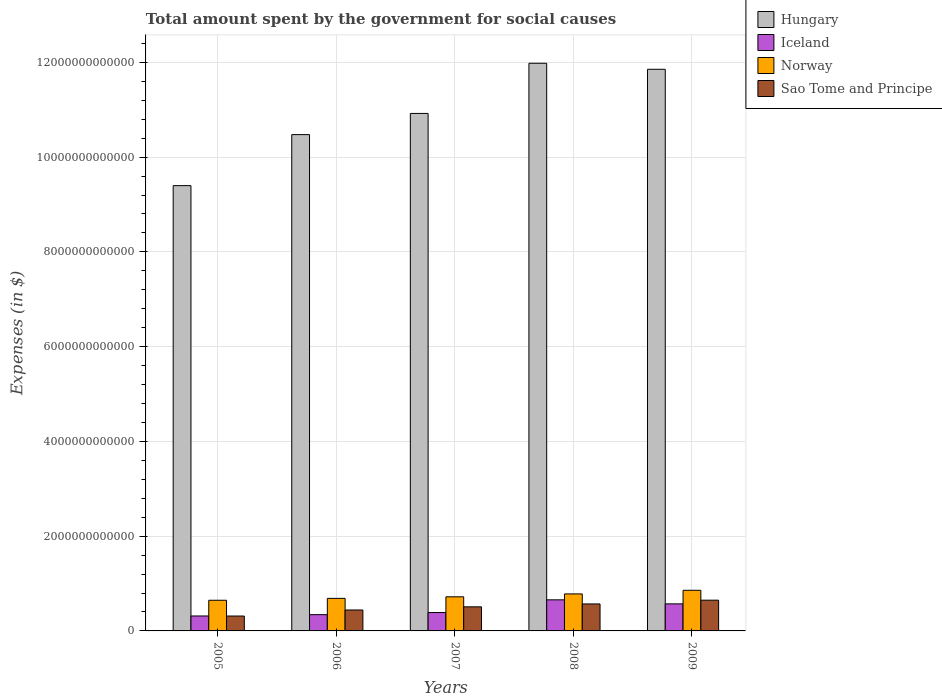How many different coloured bars are there?
Give a very brief answer. 4. How many groups of bars are there?
Offer a very short reply. 5. What is the label of the 2nd group of bars from the left?
Ensure brevity in your answer.  2006. In how many cases, is the number of bars for a given year not equal to the number of legend labels?
Provide a short and direct response. 0. What is the amount spent for social causes by the government in Iceland in 2007?
Offer a very short reply. 3.88e+11. Across all years, what is the maximum amount spent for social causes by the government in Norway?
Your answer should be compact. 8.57e+11. Across all years, what is the minimum amount spent for social causes by the government in Iceland?
Give a very brief answer. 3.16e+11. What is the total amount spent for social causes by the government in Hungary in the graph?
Your answer should be very brief. 5.46e+13. What is the difference between the amount spent for social causes by the government in Hungary in 2005 and that in 2008?
Ensure brevity in your answer.  -2.58e+12. What is the difference between the amount spent for social causes by the government in Iceland in 2008 and the amount spent for social causes by the government in Sao Tome and Principe in 2009?
Your answer should be very brief. 7.34e+09. What is the average amount spent for social causes by the government in Hungary per year?
Your answer should be compact. 1.09e+13. In the year 2009, what is the difference between the amount spent for social causes by the government in Hungary and amount spent for social causes by the government in Norway?
Ensure brevity in your answer.  1.10e+13. In how many years, is the amount spent for social causes by the government in Norway greater than 3200000000000 $?
Offer a very short reply. 0. What is the ratio of the amount spent for social causes by the government in Hungary in 2005 to that in 2009?
Give a very brief answer. 0.79. Is the amount spent for social causes by the government in Hungary in 2006 less than that in 2007?
Offer a terse response. Yes. What is the difference between the highest and the second highest amount spent for social causes by the government in Sao Tome and Principe?
Your answer should be very brief. 7.93e+1. What is the difference between the highest and the lowest amount spent for social causes by the government in Sao Tome and Principe?
Your answer should be compact. 3.34e+11. Is it the case that in every year, the sum of the amount spent for social causes by the government in Hungary and amount spent for social causes by the government in Iceland is greater than the sum of amount spent for social causes by the government in Norway and amount spent for social causes by the government in Sao Tome and Principe?
Provide a succinct answer. Yes. What does the 1st bar from the left in 2005 represents?
Your answer should be very brief. Hungary. What does the 2nd bar from the right in 2006 represents?
Your response must be concise. Norway. Is it the case that in every year, the sum of the amount spent for social causes by the government in Iceland and amount spent for social causes by the government in Sao Tome and Principe is greater than the amount spent for social causes by the government in Hungary?
Your answer should be very brief. No. Are all the bars in the graph horizontal?
Provide a succinct answer. No. How many years are there in the graph?
Provide a short and direct response. 5. What is the difference between two consecutive major ticks on the Y-axis?
Your response must be concise. 2.00e+12. Where does the legend appear in the graph?
Ensure brevity in your answer.  Top right. How are the legend labels stacked?
Your answer should be compact. Vertical. What is the title of the graph?
Your response must be concise. Total amount spent by the government for social causes. Does "Sao Tome and Principe" appear as one of the legend labels in the graph?
Give a very brief answer. Yes. What is the label or title of the Y-axis?
Keep it short and to the point. Expenses (in $). What is the Expenses (in $) of Hungary in 2005?
Provide a succinct answer. 9.40e+12. What is the Expenses (in $) of Iceland in 2005?
Ensure brevity in your answer.  3.16e+11. What is the Expenses (in $) of Norway in 2005?
Offer a terse response. 6.47e+11. What is the Expenses (in $) of Sao Tome and Principe in 2005?
Give a very brief answer. 3.14e+11. What is the Expenses (in $) in Hungary in 2006?
Offer a terse response. 1.05e+13. What is the Expenses (in $) of Iceland in 2006?
Make the answer very short. 3.44e+11. What is the Expenses (in $) of Norway in 2006?
Offer a terse response. 6.87e+11. What is the Expenses (in $) of Sao Tome and Principe in 2006?
Ensure brevity in your answer.  4.42e+11. What is the Expenses (in $) of Hungary in 2007?
Provide a short and direct response. 1.09e+13. What is the Expenses (in $) in Iceland in 2007?
Offer a very short reply. 3.88e+11. What is the Expenses (in $) of Norway in 2007?
Provide a short and direct response. 7.20e+11. What is the Expenses (in $) in Sao Tome and Principe in 2007?
Make the answer very short. 5.08e+11. What is the Expenses (in $) in Hungary in 2008?
Make the answer very short. 1.20e+13. What is the Expenses (in $) of Iceland in 2008?
Provide a short and direct response. 6.56e+11. What is the Expenses (in $) in Norway in 2008?
Provide a short and direct response. 7.81e+11. What is the Expenses (in $) in Sao Tome and Principe in 2008?
Keep it short and to the point. 5.69e+11. What is the Expenses (in $) in Hungary in 2009?
Offer a terse response. 1.19e+13. What is the Expenses (in $) in Iceland in 2009?
Offer a very short reply. 5.71e+11. What is the Expenses (in $) of Norway in 2009?
Keep it short and to the point. 8.57e+11. What is the Expenses (in $) in Sao Tome and Principe in 2009?
Offer a terse response. 6.49e+11. Across all years, what is the maximum Expenses (in $) in Hungary?
Provide a short and direct response. 1.20e+13. Across all years, what is the maximum Expenses (in $) of Iceland?
Offer a terse response. 6.56e+11. Across all years, what is the maximum Expenses (in $) in Norway?
Your answer should be compact. 8.57e+11. Across all years, what is the maximum Expenses (in $) of Sao Tome and Principe?
Keep it short and to the point. 6.49e+11. Across all years, what is the minimum Expenses (in $) of Hungary?
Give a very brief answer. 9.40e+12. Across all years, what is the minimum Expenses (in $) in Iceland?
Keep it short and to the point. 3.16e+11. Across all years, what is the minimum Expenses (in $) in Norway?
Your response must be concise. 6.47e+11. Across all years, what is the minimum Expenses (in $) in Sao Tome and Principe?
Make the answer very short. 3.14e+11. What is the total Expenses (in $) of Hungary in the graph?
Ensure brevity in your answer.  5.46e+13. What is the total Expenses (in $) of Iceland in the graph?
Offer a very short reply. 2.27e+12. What is the total Expenses (in $) in Norway in the graph?
Give a very brief answer. 3.69e+12. What is the total Expenses (in $) in Sao Tome and Principe in the graph?
Your answer should be compact. 2.48e+12. What is the difference between the Expenses (in $) in Hungary in 2005 and that in 2006?
Your answer should be very brief. -1.08e+12. What is the difference between the Expenses (in $) in Iceland in 2005 and that in 2006?
Give a very brief answer. -2.80e+1. What is the difference between the Expenses (in $) in Norway in 2005 and that in 2006?
Give a very brief answer. -4.02e+1. What is the difference between the Expenses (in $) of Sao Tome and Principe in 2005 and that in 2006?
Your response must be concise. -1.27e+11. What is the difference between the Expenses (in $) in Hungary in 2005 and that in 2007?
Keep it short and to the point. -1.52e+12. What is the difference between the Expenses (in $) of Iceland in 2005 and that in 2007?
Make the answer very short. -7.25e+1. What is the difference between the Expenses (in $) of Norway in 2005 and that in 2007?
Make the answer very short. -7.31e+1. What is the difference between the Expenses (in $) of Sao Tome and Principe in 2005 and that in 2007?
Offer a terse response. -1.94e+11. What is the difference between the Expenses (in $) of Hungary in 2005 and that in 2008?
Provide a succinct answer. -2.58e+12. What is the difference between the Expenses (in $) of Iceland in 2005 and that in 2008?
Ensure brevity in your answer.  -3.41e+11. What is the difference between the Expenses (in $) in Norway in 2005 and that in 2008?
Your answer should be very brief. -1.34e+11. What is the difference between the Expenses (in $) in Sao Tome and Principe in 2005 and that in 2008?
Offer a very short reply. -2.55e+11. What is the difference between the Expenses (in $) in Hungary in 2005 and that in 2009?
Your answer should be very brief. -2.46e+12. What is the difference between the Expenses (in $) in Iceland in 2005 and that in 2009?
Give a very brief answer. -2.55e+11. What is the difference between the Expenses (in $) of Norway in 2005 and that in 2009?
Provide a succinct answer. -2.10e+11. What is the difference between the Expenses (in $) in Sao Tome and Principe in 2005 and that in 2009?
Provide a short and direct response. -3.34e+11. What is the difference between the Expenses (in $) of Hungary in 2006 and that in 2007?
Keep it short and to the point. -4.47e+11. What is the difference between the Expenses (in $) of Iceland in 2006 and that in 2007?
Provide a succinct answer. -4.45e+1. What is the difference between the Expenses (in $) of Norway in 2006 and that in 2007?
Ensure brevity in your answer.  -3.29e+1. What is the difference between the Expenses (in $) in Sao Tome and Principe in 2006 and that in 2007?
Give a very brief answer. -6.67e+1. What is the difference between the Expenses (in $) of Hungary in 2006 and that in 2008?
Provide a succinct answer. -1.51e+12. What is the difference between the Expenses (in $) in Iceland in 2006 and that in 2008?
Provide a succinct answer. -3.13e+11. What is the difference between the Expenses (in $) of Norway in 2006 and that in 2008?
Provide a succinct answer. -9.35e+1. What is the difference between the Expenses (in $) in Sao Tome and Principe in 2006 and that in 2008?
Provide a short and direct response. -1.28e+11. What is the difference between the Expenses (in $) of Hungary in 2006 and that in 2009?
Your answer should be compact. -1.38e+12. What is the difference between the Expenses (in $) in Iceland in 2006 and that in 2009?
Your answer should be very brief. -2.27e+11. What is the difference between the Expenses (in $) in Norway in 2006 and that in 2009?
Your answer should be very brief. -1.70e+11. What is the difference between the Expenses (in $) of Sao Tome and Principe in 2006 and that in 2009?
Your response must be concise. -2.07e+11. What is the difference between the Expenses (in $) of Hungary in 2007 and that in 2008?
Offer a very short reply. -1.06e+12. What is the difference between the Expenses (in $) of Iceland in 2007 and that in 2008?
Provide a short and direct response. -2.68e+11. What is the difference between the Expenses (in $) in Norway in 2007 and that in 2008?
Offer a terse response. -6.06e+1. What is the difference between the Expenses (in $) of Sao Tome and Principe in 2007 and that in 2008?
Provide a succinct answer. -6.10e+1. What is the difference between the Expenses (in $) in Hungary in 2007 and that in 2009?
Offer a terse response. -9.32e+11. What is the difference between the Expenses (in $) of Iceland in 2007 and that in 2009?
Ensure brevity in your answer.  -1.83e+11. What is the difference between the Expenses (in $) of Norway in 2007 and that in 2009?
Ensure brevity in your answer.  -1.37e+11. What is the difference between the Expenses (in $) of Sao Tome and Principe in 2007 and that in 2009?
Make the answer very short. -1.40e+11. What is the difference between the Expenses (in $) in Hungary in 2008 and that in 2009?
Ensure brevity in your answer.  1.27e+11. What is the difference between the Expenses (in $) in Iceland in 2008 and that in 2009?
Offer a very short reply. 8.54e+1. What is the difference between the Expenses (in $) of Norway in 2008 and that in 2009?
Offer a very short reply. -7.68e+1. What is the difference between the Expenses (in $) in Sao Tome and Principe in 2008 and that in 2009?
Offer a terse response. -7.93e+1. What is the difference between the Expenses (in $) in Hungary in 2005 and the Expenses (in $) in Iceland in 2006?
Make the answer very short. 9.05e+12. What is the difference between the Expenses (in $) in Hungary in 2005 and the Expenses (in $) in Norway in 2006?
Provide a short and direct response. 8.71e+12. What is the difference between the Expenses (in $) in Hungary in 2005 and the Expenses (in $) in Sao Tome and Principe in 2006?
Ensure brevity in your answer.  8.96e+12. What is the difference between the Expenses (in $) of Iceland in 2005 and the Expenses (in $) of Norway in 2006?
Give a very brief answer. -3.72e+11. What is the difference between the Expenses (in $) in Iceland in 2005 and the Expenses (in $) in Sao Tome and Principe in 2006?
Provide a short and direct response. -1.26e+11. What is the difference between the Expenses (in $) of Norway in 2005 and the Expenses (in $) of Sao Tome and Principe in 2006?
Keep it short and to the point. 2.05e+11. What is the difference between the Expenses (in $) in Hungary in 2005 and the Expenses (in $) in Iceland in 2007?
Your answer should be compact. 9.01e+12. What is the difference between the Expenses (in $) of Hungary in 2005 and the Expenses (in $) of Norway in 2007?
Provide a short and direct response. 8.68e+12. What is the difference between the Expenses (in $) of Hungary in 2005 and the Expenses (in $) of Sao Tome and Principe in 2007?
Ensure brevity in your answer.  8.89e+12. What is the difference between the Expenses (in $) in Iceland in 2005 and the Expenses (in $) in Norway in 2007?
Give a very brief answer. -4.05e+11. What is the difference between the Expenses (in $) of Iceland in 2005 and the Expenses (in $) of Sao Tome and Principe in 2007?
Ensure brevity in your answer.  -1.93e+11. What is the difference between the Expenses (in $) in Norway in 2005 and the Expenses (in $) in Sao Tome and Principe in 2007?
Your response must be concise. 1.39e+11. What is the difference between the Expenses (in $) in Hungary in 2005 and the Expenses (in $) in Iceland in 2008?
Offer a terse response. 8.74e+12. What is the difference between the Expenses (in $) of Hungary in 2005 and the Expenses (in $) of Norway in 2008?
Make the answer very short. 8.62e+12. What is the difference between the Expenses (in $) in Hungary in 2005 and the Expenses (in $) in Sao Tome and Principe in 2008?
Give a very brief answer. 8.83e+12. What is the difference between the Expenses (in $) in Iceland in 2005 and the Expenses (in $) in Norway in 2008?
Ensure brevity in your answer.  -4.65e+11. What is the difference between the Expenses (in $) in Iceland in 2005 and the Expenses (in $) in Sao Tome and Principe in 2008?
Ensure brevity in your answer.  -2.54e+11. What is the difference between the Expenses (in $) in Norway in 2005 and the Expenses (in $) in Sao Tome and Principe in 2008?
Your response must be concise. 7.76e+1. What is the difference between the Expenses (in $) in Hungary in 2005 and the Expenses (in $) in Iceland in 2009?
Provide a succinct answer. 8.83e+12. What is the difference between the Expenses (in $) in Hungary in 2005 and the Expenses (in $) in Norway in 2009?
Give a very brief answer. 8.54e+12. What is the difference between the Expenses (in $) of Hungary in 2005 and the Expenses (in $) of Sao Tome and Principe in 2009?
Offer a terse response. 8.75e+12. What is the difference between the Expenses (in $) of Iceland in 2005 and the Expenses (in $) of Norway in 2009?
Your response must be concise. -5.42e+11. What is the difference between the Expenses (in $) of Iceland in 2005 and the Expenses (in $) of Sao Tome and Principe in 2009?
Ensure brevity in your answer.  -3.33e+11. What is the difference between the Expenses (in $) of Norway in 2005 and the Expenses (in $) of Sao Tome and Principe in 2009?
Your response must be concise. -1.75e+09. What is the difference between the Expenses (in $) in Hungary in 2006 and the Expenses (in $) in Iceland in 2007?
Offer a terse response. 1.01e+13. What is the difference between the Expenses (in $) in Hungary in 2006 and the Expenses (in $) in Norway in 2007?
Ensure brevity in your answer.  9.75e+12. What is the difference between the Expenses (in $) of Hungary in 2006 and the Expenses (in $) of Sao Tome and Principe in 2007?
Your response must be concise. 9.97e+12. What is the difference between the Expenses (in $) in Iceland in 2006 and the Expenses (in $) in Norway in 2007?
Your response must be concise. -3.77e+11. What is the difference between the Expenses (in $) of Iceland in 2006 and the Expenses (in $) of Sao Tome and Principe in 2007?
Give a very brief answer. -1.65e+11. What is the difference between the Expenses (in $) of Norway in 2006 and the Expenses (in $) of Sao Tome and Principe in 2007?
Give a very brief answer. 1.79e+11. What is the difference between the Expenses (in $) in Hungary in 2006 and the Expenses (in $) in Iceland in 2008?
Provide a succinct answer. 9.82e+12. What is the difference between the Expenses (in $) in Hungary in 2006 and the Expenses (in $) in Norway in 2008?
Your answer should be compact. 9.69e+12. What is the difference between the Expenses (in $) in Hungary in 2006 and the Expenses (in $) in Sao Tome and Principe in 2008?
Provide a short and direct response. 9.91e+12. What is the difference between the Expenses (in $) of Iceland in 2006 and the Expenses (in $) of Norway in 2008?
Your answer should be compact. -4.37e+11. What is the difference between the Expenses (in $) in Iceland in 2006 and the Expenses (in $) in Sao Tome and Principe in 2008?
Offer a terse response. -2.26e+11. What is the difference between the Expenses (in $) in Norway in 2006 and the Expenses (in $) in Sao Tome and Principe in 2008?
Your answer should be compact. 1.18e+11. What is the difference between the Expenses (in $) of Hungary in 2006 and the Expenses (in $) of Iceland in 2009?
Provide a succinct answer. 9.90e+12. What is the difference between the Expenses (in $) of Hungary in 2006 and the Expenses (in $) of Norway in 2009?
Provide a succinct answer. 9.62e+12. What is the difference between the Expenses (in $) in Hungary in 2006 and the Expenses (in $) in Sao Tome and Principe in 2009?
Make the answer very short. 9.83e+12. What is the difference between the Expenses (in $) in Iceland in 2006 and the Expenses (in $) in Norway in 2009?
Keep it short and to the point. -5.14e+11. What is the difference between the Expenses (in $) of Iceland in 2006 and the Expenses (in $) of Sao Tome and Principe in 2009?
Your answer should be compact. -3.05e+11. What is the difference between the Expenses (in $) in Norway in 2006 and the Expenses (in $) in Sao Tome and Principe in 2009?
Provide a short and direct response. 3.84e+1. What is the difference between the Expenses (in $) in Hungary in 2007 and the Expenses (in $) in Iceland in 2008?
Offer a very short reply. 1.03e+13. What is the difference between the Expenses (in $) of Hungary in 2007 and the Expenses (in $) of Norway in 2008?
Your answer should be very brief. 1.01e+13. What is the difference between the Expenses (in $) in Hungary in 2007 and the Expenses (in $) in Sao Tome and Principe in 2008?
Ensure brevity in your answer.  1.04e+13. What is the difference between the Expenses (in $) in Iceland in 2007 and the Expenses (in $) in Norway in 2008?
Keep it short and to the point. -3.93e+11. What is the difference between the Expenses (in $) of Iceland in 2007 and the Expenses (in $) of Sao Tome and Principe in 2008?
Provide a short and direct response. -1.81e+11. What is the difference between the Expenses (in $) of Norway in 2007 and the Expenses (in $) of Sao Tome and Principe in 2008?
Provide a short and direct response. 1.51e+11. What is the difference between the Expenses (in $) of Hungary in 2007 and the Expenses (in $) of Iceland in 2009?
Keep it short and to the point. 1.04e+13. What is the difference between the Expenses (in $) in Hungary in 2007 and the Expenses (in $) in Norway in 2009?
Make the answer very short. 1.01e+13. What is the difference between the Expenses (in $) in Hungary in 2007 and the Expenses (in $) in Sao Tome and Principe in 2009?
Keep it short and to the point. 1.03e+13. What is the difference between the Expenses (in $) in Iceland in 2007 and the Expenses (in $) in Norway in 2009?
Your answer should be compact. -4.69e+11. What is the difference between the Expenses (in $) of Iceland in 2007 and the Expenses (in $) of Sao Tome and Principe in 2009?
Make the answer very short. -2.61e+11. What is the difference between the Expenses (in $) of Norway in 2007 and the Expenses (in $) of Sao Tome and Principe in 2009?
Ensure brevity in your answer.  7.13e+1. What is the difference between the Expenses (in $) in Hungary in 2008 and the Expenses (in $) in Iceland in 2009?
Offer a terse response. 1.14e+13. What is the difference between the Expenses (in $) of Hungary in 2008 and the Expenses (in $) of Norway in 2009?
Your answer should be compact. 1.11e+13. What is the difference between the Expenses (in $) of Hungary in 2008 and the Expenses (in $) of Sao Tome and Principe in 2009?
Offer a very short reply. 1.13e+13. What is the difference between the Expenses (in $) in Iceland in 2008 and the Expenses (in $) in Norway in 2009?
Your answer should be very brief. -2.01e+11. What is the difference between the Expenses (in $) in Iceland in 2008 and the Expenses (in $) in Sao Tome and Principe in 2009?
Your answer should be very brief. 7.34e+09. What is the difference between the Expenses (in $) of Norway in 2008 and the Expenses (in $) of Sao Tome and Principe in 2009?
Offer a terse response. 1.32e+11. What is the average Expenses (in $) of Hungary per year?
Ensure brevity in your answer.  1.09e+13. What is the average Expenses (in $) in Iceland per year?
Your answer should be compact. 4.55e+11. What is the average Expenses (in $) of Norway per year?
Your answer should be compact. 7.39e+11. What is the average Expenses (in $) of Sao Tome and Principe per year?
Provide a succinct answer. 4.97e+11. In the year 2005, what is the difference between the Expenses (in $) of Hungary and Expenses (in $) of Iceland?
Ensure brevity in your answer.  9.08e+12. In the year 2005, what is the difference between the Expenses (in $) in Hungary and Expenses (in $) in Norway?
Provide a short and direct response. 8.75e+12. In the year 2005, what is the difference between the Expenses (in $) of Hungary and Expenses (in $) of Sao Tome and Principe?
Offer a very short reply. 9.08e+12. In the year 2005, what is the difference between the Expenses (in $) in Iceland and Expenses (in $) in Norway?
Your response must be concise. -3.31e+11. In the year 2005, what is the difference between the Expenses (in $) in Iceland and Expenses (in $) in Sao Tome and Principe?
Make the answer very short. 1.15e+09. In the year 2005, what is the difference between the Expenses (in $) of Norway and Expenses (in $) of Sao Tome and Principe?
Provide a succinct answer. 3.33e+11. In the year 2006, what is the difference between the Expenses (in $) of Hungary and Expenses (in $) of Iceland?
Make the answer very short. 1.01e+13. In the year 2006, what is the difference between the Expenses (in $) in Hungary and Expenses (in $) in Norway?
Make the answer very short. 9.79e+12. In the year 2006, what is the difference between the Expenses (in $) in Hungary and Expenses (in $) in Sao Tome and Principe?
Your response must be concise. 1.00e+13. In the year 2006, what is the difference between the Expenses (in $) of Iceland and Expenses (in $) of Norway?
Provide a short and direct response. -3.44e+11. In the year 2006, what is the difference between the Expenses (in $) of Iceland and Expenses (in $) of Sao Tome and Principe?
Your answer should be very brief. -9.82e+1. In the year 2006, what is the difference between the Expenses (in $) in Norway and Expenses (in $) in Sao Tome and Principe?
Provide a short and direct response. 2.45e+11. In the year 2007, what is the difference between the Expenses (in $) in Hungary and Expenses (in $) in Iceland?
Offer a terse response. 1.05e+13. In the year 2007, what is the difference between the Expenses (in $) in Hungary and Expenses (in $) in Norway?
Give a very brief answer. 1.02e+13. In the year 2007, what is the difference between the Expenses (in $) of Hungary and Expenses (in $) of Sao Tome and Principe?
Provide a succinct answer. 1.04e+13. In the year 2007, what is the difference between the Expenses (in $) of Iceland and Expenses (in $) of Norway?
Keep it short and to the point. -3.32e+11. In the year 2007, what is the difference between the Expenses (in $) of Iceland and Expenses (in $) of Sao Tome and Principe?
Provide a short and direct response. -1.20e+11. In the year 2007, what is the difference between the Expenses (in $) of Norway and Expenses (in $) of Sao Tome and Principe?
Your response must be concise. 2.12e+11. In the year 2008, what is the difference between the Expenses (in $) of Hungary and Expenses (in $) of Iceland?
Your response must be concise. 1.13e+13. In the year 2008, what is the difference between the Expenses (in $) of Hungary and Expenses (in $) of Norway?
Ensure brevity in your answer.  1.12e+13. In the year 2008, what is the difference between the Expenses (in $) of Hungary and Expenses (in $) of Sao Tome and Principe?
Ensure brevity in your answer.  1.14e+13. In the year 2008, what is the difference between the Expenses (in $) in Iceland and Expenses (in $) in Norway?
Keep it short and to the point. -1.25e+11. In the year 2008, what is the difference between the Expenses (in $) in Iceland and Expenses (in $) in Sao Tome and Principe?
Provide a short and direct response. 8.67e+1. In the year 2008, what is the difference between the Expenses (in $) of Norway and Expenses (in $) of Sao Tome and Principe?
Offer a very short reply. 2.11e+11. In the year 2009, what is the difference between the Expenses (in $) of Hungary and Expenses (in $) of Iceland?
Offer a terse response. 1.13e+13. In the year 2009, what is the difference between the Expenses (in $) in Hungary and Expenses (in $) in Norway?
Keep it short and to the point. 1.10e+13. In the year 2009, what is the difference between the Expenses (in $) in Hungary and Expenses (in $) in Sao Tome and Principe?
Offer a terse response. 1.12e+13. In the year 2009, what is the difference between the Expenses (in $) of Iceland and Expenses (in $) of Norway?
Provide a short and direct response. -2.87e+11. In the year 2009, what is the difference between the Expenses (in $) in Iceland and Expenses (in $) in Sao Tome and Principe?
Your answer should be compact. -7.81e+1. In the year 2009, what is the difference between the Expenses (in $) of Norway and Expenses (in $) of Sao Tome and Principe?
Your answer should be very brief. 2.09e+11. What is the ratio of the Expenses (in $) of Hungary in 2005 to that in 2006?
Offer a very short reply. 0.9. What is the ratio of the Expenses (in $) in Iceland in 2005 to that in 2006?
Your answer should be compact. 0.92. What is the ratio of the Expenses (in $) of Norway in 2005 to that in 2006?
Give a very brief answer. 0.94. What is the ratio of the Expenses (in $) of Sao Tome and Principe in 2005 to that in 2006?
Your answer should be very brief. 0.71. What is the ratio of the Expenses (in $) of Hungary in 2005 to that in 2007?
Your answer should be compact. 0.86. What is the ratio of the Expenses (in $) of Iceland in 2005 to that in 2007?
Provide a succinct answer. 0.81. What is the ratio of the Expenses (in $) in Norway in 2005 to that in 2007?
Your answer should be very brief. 0.9. What is the ratio of the Expenses (in $) of Sao Tome and Principe in 2005 to that in 2007?
Your answer should be compact. 0.62. What is the ratio of the Expenses (in $) in Hungary in 2005 to that in 2008?
Ensure brevity in your answer.  0.78. What is the ratio of the Expenses (in $) in Iceland in 2005 to that in 2008?
Offer a very short reply. 0.48. What is the ratio of the Expenses (in $) in Norway in 2005 to that in 2008?
Offer a very short reply. 0.83. What is the ratio of the Expenses (in $) in Sao Tome and Principe in 2005 to that in 2008?
Provide a short and direct response. 0.55. What is the ratio of the Expenses (in $) in Hungary in 2005 to that in 2009?
Your answer should be compact. 0.79. What is the ratio of the Expenses (in $) in Iceland in 2005 to that in 2009?
Make the answer very short. 0.55. What is the ratio of the Expenses (in $) of Norway in 2005 to that in 2009?
Provide a short and direct response. 0.75. What is the ratio of the Expenses (in $) in Sao Tome and Principe in 2005 to that in 2009?
Ensure brevity in your answer.  0.48. What is the ratio of the Expenses (in $) in Hungary in 2006 to that in 2007?
Provide a succinct answer. 0.96. What is the ratio of the Expenses (in $) of Iceland in 2006 to that in 2007?
Your answer should be compact. 0.89. What is the ratio of the Expenses (in $) of Norway in 2006 to that in 2007?
Offer a terse response. 0.95. What is the ratio of the Expenses (in $) in Sao Tome and Principe in 2006 to that in 2007?
Your answer should be compact. 0.87. What is the ratio of the Expenses (in $) in Hungary in 2006 to that in 2008?
Offer a terse response. 0.87. What is the ratio of the Expenses (in $) of Iceland in 2006 to that in 2008?
Your answer should be very brief. 0.52. What is the ratio of the Expenses (in $) of Norway in 2006 to that in 2008?
Your answer should be compact. 0.88. What is the ratio of the Expenses (in $) of Sao Tome and Principe in 2006 to that in 2008?
Provide a short and direct response. 0.78. What is the ratio of the Expenses (in $) of Hungary in 2006 to that in 2009?
Offer a very short reply. 0.88. What is the ratio of the Expenses (in $) of Iceland in 2006 to that in 2009?
Your answer should be compact. 0.6. What is the ratio of the Expenses (in $) of Norway in 2006 to that in 2009?
Provide a succinct answer. 0.8. What is the ratio of the Expenses (in $) of Sao Tome and Principe in 2006 to that in 2009?
Your answer should be very brief. 0.68. What is the ratio of the Expenses (in $) of Hungary in 2007 to that in 2008?
Make the answer very short. 0.91. What is the ratio of the Expenses (in $) of Iceland in 2007 to that in 2008?
Give a very brief answer. 0.59. What is the ratio of the Expenses (in $) of Norway in 2007 to that in 2008?
Offer a terse response. 0.92. What is the ratio of the Expenses (in $) in Sao Tome and Principe in 2007 to that in 2008?
Make the answer very short. 0.89. What is the ratio of the Expenses (in $) of Hungary in 2007 to that in 2009?
Provide a short and direct response. 0.92. What is the ratio of the Expenses (in $) of Iceland in 2007 to that in 2009?
Offer a terse response. 0.68. What is the ratio of the Expenses (in $) in Norway in 2007 to that in 2009?
Offer a terse response. 0.84. What is the ratio of the Expenses (in $) in Sao Tome and Principe in 2007 to that in 2009?
Make the answer very short. 0.78. What is the ratio of the Expenses (in $) in Hungary in 2008 to that in 2009?
Give a very brief answer. 1.01. What is the ratio of the Expenses (in $) in Iceland in 2008 to that in 2009?
Provide a succinct answer. 1.15. What is the ratio of the Expenses (in $) in Norway in 2008 to that in 2009?
Provide a short and direct response. 0.91. What is the ratio of the Expenses (in $) in Sao Tome and Principe in 2008 to that in 2009?
Offer a terse response. 0.88. What is the difference between the highest and the second highest Expenses (in $) in Hungary?
Make the answer very short. 1.27e+11. What is the difference between the highest and the second highest Expenses (in $) of Iceland?
Provide a succinct answer. 8.54e+1. What is the difference between the highest and the second highest Expenses (in $) in Norway?
Provide a succinct answer. 7.68e+1. What is the difference between the highest and the second highest Expenses (in $) of Sao Tome and Principe?
Your answer should be compact. 7.93e+1. What is the difference between the highest and the lowest Expenses (in $) in Hungary?
Give a very brief answer. 2.58e+12. What is the difference between the highest and the lowest Expenses (in $) in Iceland?
Provide a succinct answer. 3.41e+11. What is the difference between the highest and the lowest Expenses (in $) in Norway?
Provide a short and direct response. 2.10e+11. What is the difference between the highest and the lowest Expenses (in $) of Sao Tome and Principe?
Keep it short and to the point. 3.34e+11. 